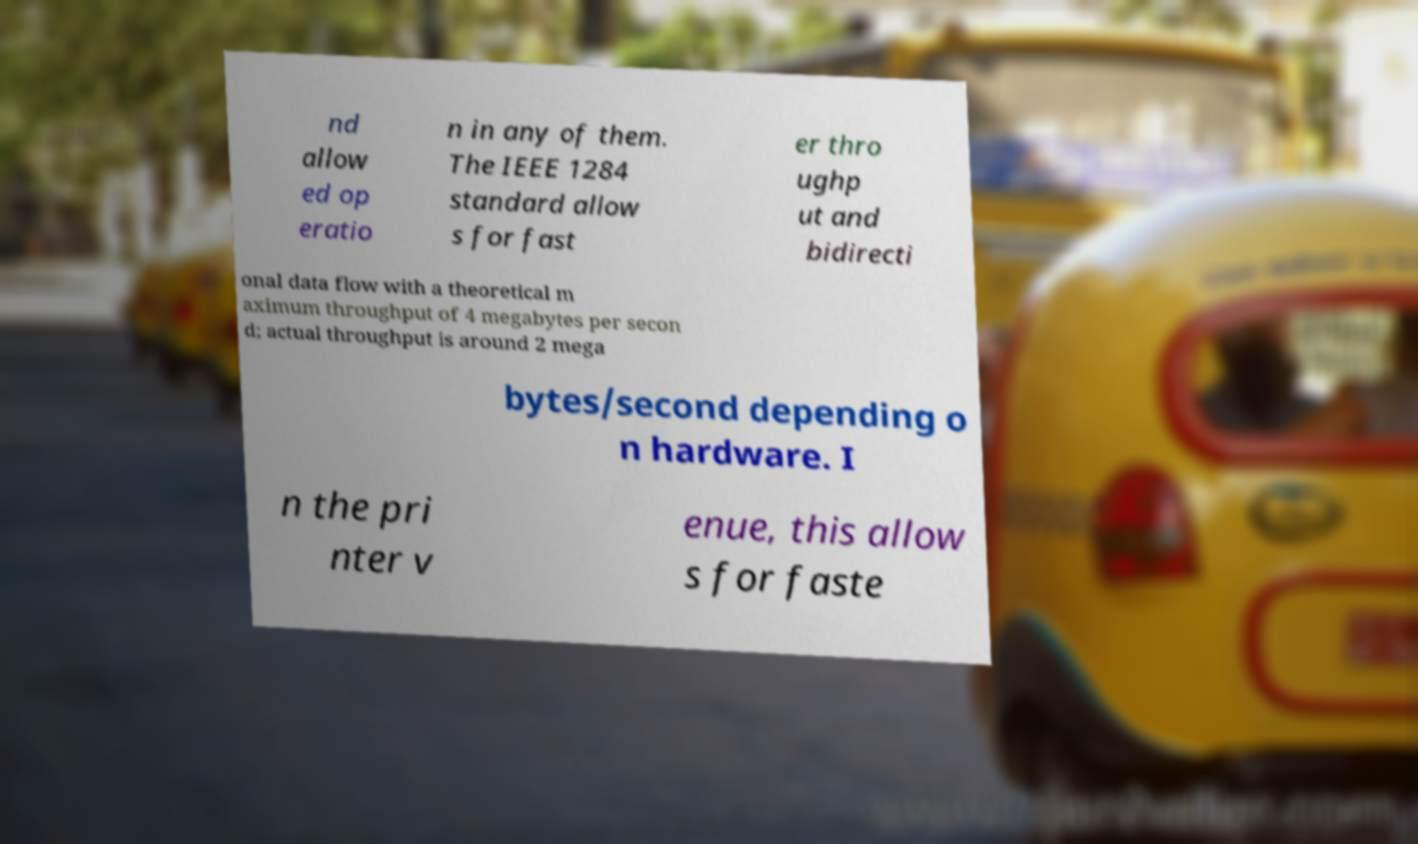Please identify and transcribe the text found in this image. nd allow ed op eratio n in any of them. The IEEE 1284 standard allow s for fast er thro ughp ut and bidirecti onal data flow with a theoretical m aximum throughput of 4 megabytes per secon d; actual throughput is around 2 mega bytes/second depending o n hardware. I n the pri nter v enue, this allow s for faste 